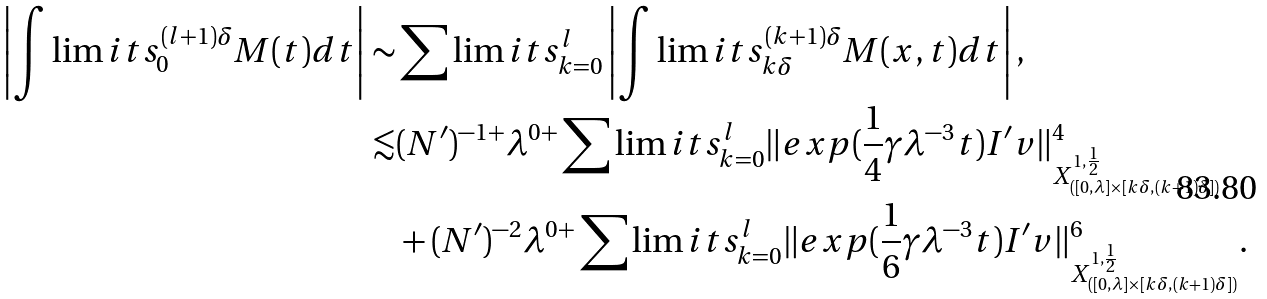<formula> <loc_0><loc_0><loc_500><loc_500>\left | \int \lim i t s _ { 0 } ^ { ( l + 1 ) \delta } M ( t ) d t \right | \sim & \sum \lim i t s _ { k = 0 } ^ { l } \left | \int \lim i t s _ { k \delta } ^ { ( k + 1 ) \delta } M ( x , t ) d t \right | , \\ \lesssim & ( N ^ { \prime } ) ^ { - 1 + } \lambda ^ { 0 + } \sum \lim i t s _ { k = 0 } ^ { l } \| e x p ( \frac { 1 } { 4 } \gamma \lambda ^ { - 3 } t ) I ^ { \prime } v \| _ { X ^ { 1 , \frac { 1 } { 2 } } _ { ( [ 0 , \lambda ] \times [ k \delta , ( k + 1 ) \delta ] ) } } ^ { 4 } \\ & + ( N ^ { \prime } ) ^ { - 2 } \lambda ^ { 0 + } \sum \lim i t s _ { k = 0 } ^ { l } \| e x p ( \frac { 1 } { 6 } \gamma \lambda ^ { - 3 } t ) I ^ { \prime } v \| _ { X ^ { 1 , \frac { 1 } { 2 } } _ { ( [ 0 , \lambda ] \times [ k \delta , ( k + 1 ) \delta ] ) } } ^ { 6 } .</formula> 